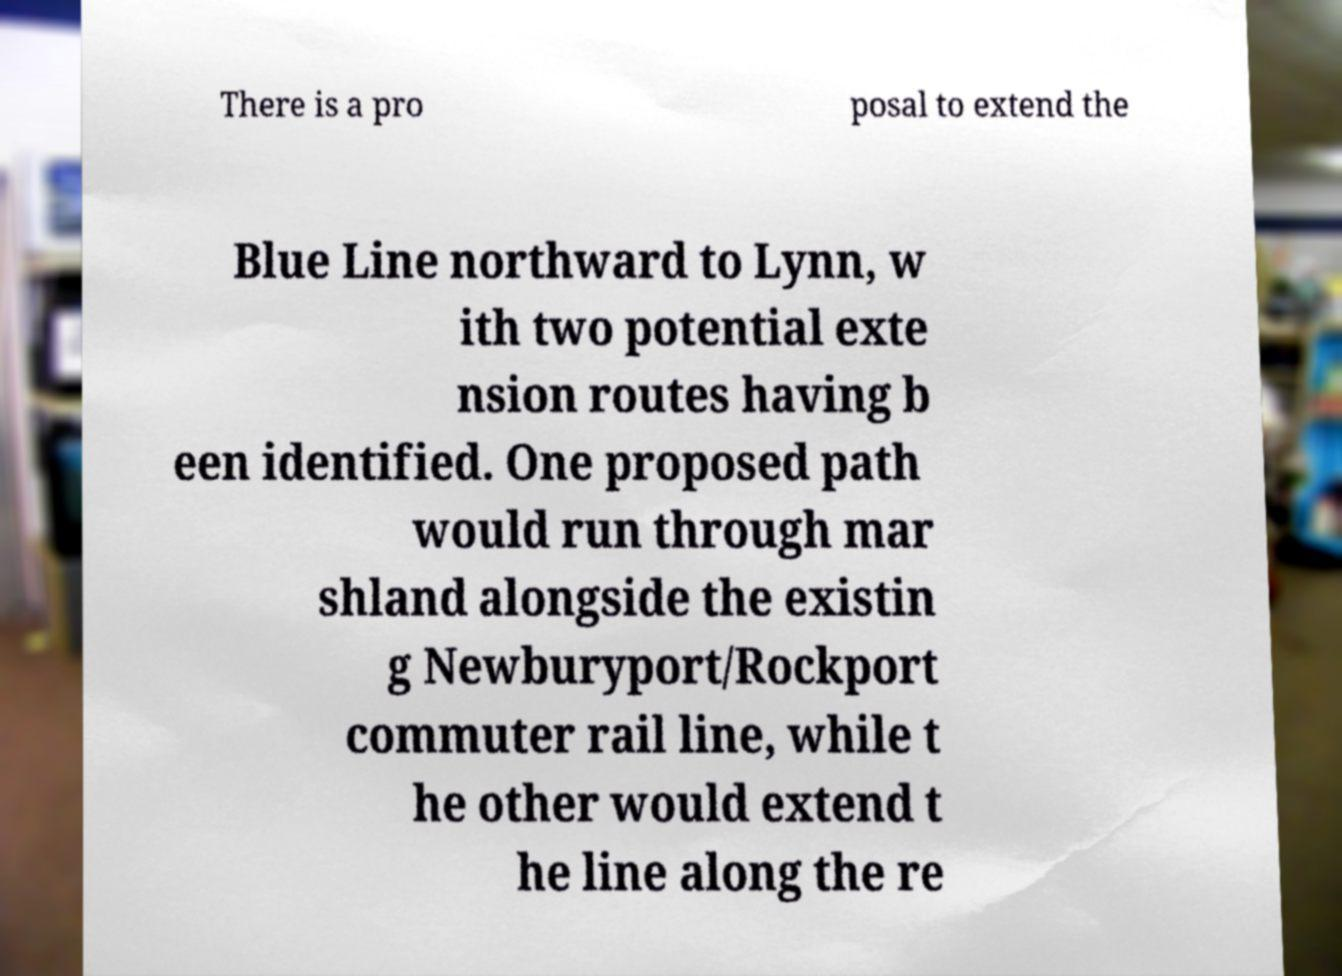Please identify and transcribe the text found in this image. There is a pro posal to extend the Blue Line northward to Lynn, w ith two potential exte nsion routes having b een identified. One proposed path would run through mar shland alongside the existin g Newburyport/Rockport commuter rail line, while t he other would extend t he line along the re 